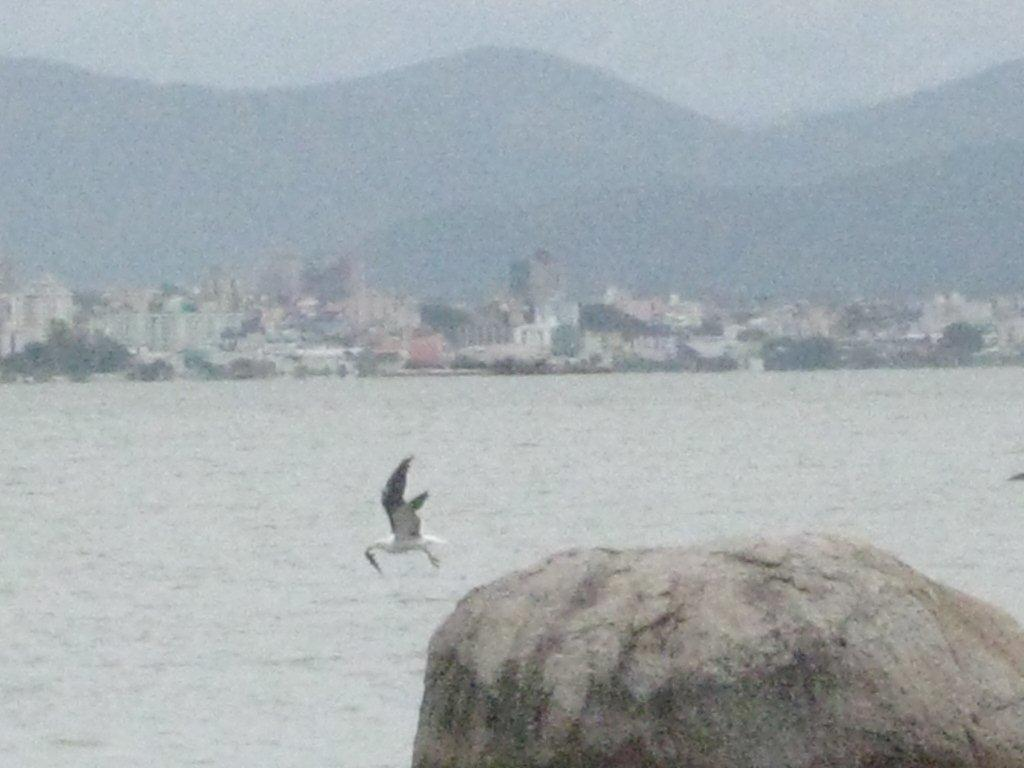What type of structures can be seen in the image? There are buildings in the image. What natural features are present in the image? There are mountains and water visible in the image. Can you describe any other objects or elements in the image? There is a rock in the image, and a bird is flying in the air. What is the price of the lace in the image? There is no lace present in the image, so it is not possible to determine its price. Can you describe the stream in the image? There is no stream present in the image; it features buildings, mountains, water, a rock, and a flying bird. 